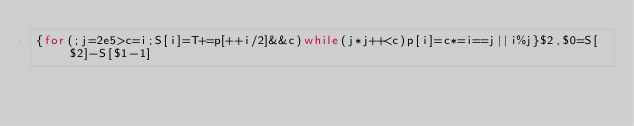<code> <loc_0><loc_0><loc_500><loc_500><_Awk_>{for(;j=2e5>c=i;S[i]=T+=p[++i/2]&&c)while(j*j++<c)p[i]=c*=i==j||i%j}$2,$0=S[$2]-S[$1-1]</code> 